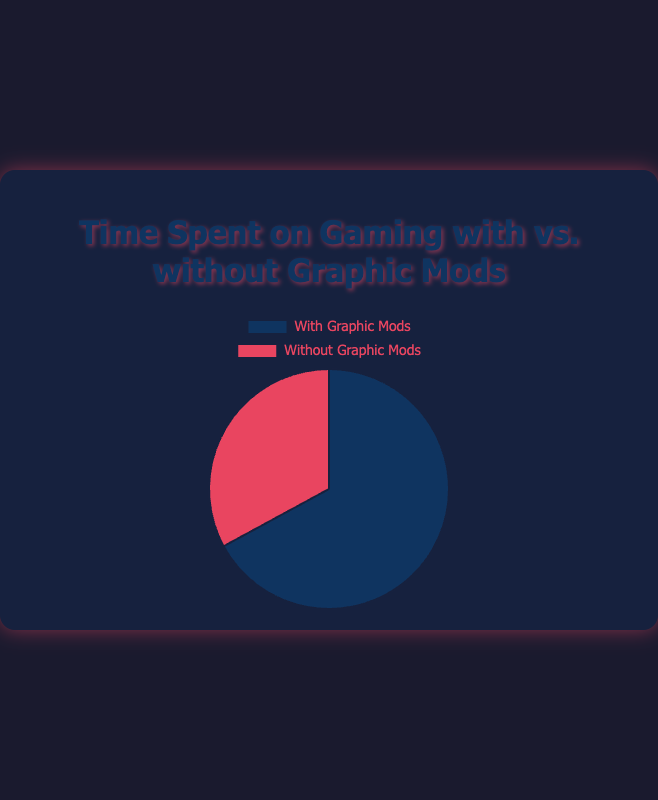Which category shows the higher total gaming time? To determine the category with the higher total gaming time, sum the hours for both "With Graphic Mods" and "Without Graphic Mods". The total time with mods is 540 hours (120 + 80 + 150 + 90 + 100), and without mods is 265 hours (40 + 50 + 100 + 30 + 45). Since 540 is greater than 265, "With Graphic Mods" has the higher total gaming time.
Answer: With Graphic Mods Which category displays the smaller portion of the pie? The smaller portion of the pie corresponds to the "Without Graphic Mods" category, which visually occupies less space compared to the "With Graphic Mods" category.
Answer: Without Graphic Mods What is the percentage of time spent gaming with graphic mods? To find the percentage, use the formula: (time spent with mods / total time) * 100. The total time is 805 hours (540 hours with mods + 265 hours without mods). The time spent with mods is 540 hours. So, (540 / 805) * 100 ≈ 67.08%.
Answer: 67.08% How much more time is spent on gaming with graphic mods compared to without? Subtract the total time without mods from the total time with mods. The total time with mods is 540 hours, and without mods is 265 hours. So, 540 - 265 = 275 hours.
Answer: 275 hours What is the average time spent on gaming for each category? To find the average, divide the total time by the number of data points (games), which is 5. For "With Graphic Mods": 540 / 5 = 108 hours. For "Without Graphic Mods": 265 / 5 = 53 hours.
Answer: With Mods: 108 hours, Without Mods: 53 hours Which category has the most significant visual impact in terms of the pie chart color? The "With Graphic Mods" category has the most significant visual impact because it occupies a larger portion of the pie chart and is represented by a darker color compared to the "Without Graphic Mods" category.
Answer: With Graphic Mods Considering the total time spent gaming with mods and without mods, how does the visual proportion relate to the actual time difference? The visual proportion in the pie chart reflects the actual time difference by showing the larger portion for "With Graphic Mods" (540 hours) and a smaller portion for "Without Graphic Mods" (265 hours) in the context of the total 805 gaming hours.
Answer: The proportion aligns How does the choice of color help in distinguishing between gaming with mods and without mods? The choice of distinct colors (blue for with mods and red for without mods) helps to easily distinguish between the two categories on the pie chart, making it visually clear which portion corresponds to which category.
Answer: Distinct colors make it clear What is the sum of time spent gaming on The Elder Scrolls V: Skyrim, both with and without graphic mods? Add the time spent with mods (120 hours) to the time spent without mods (40 hours) for The Elder Scrolls V: Skyrim. So, 120 + 40 = 160 hours.
Answer: 160 hours 